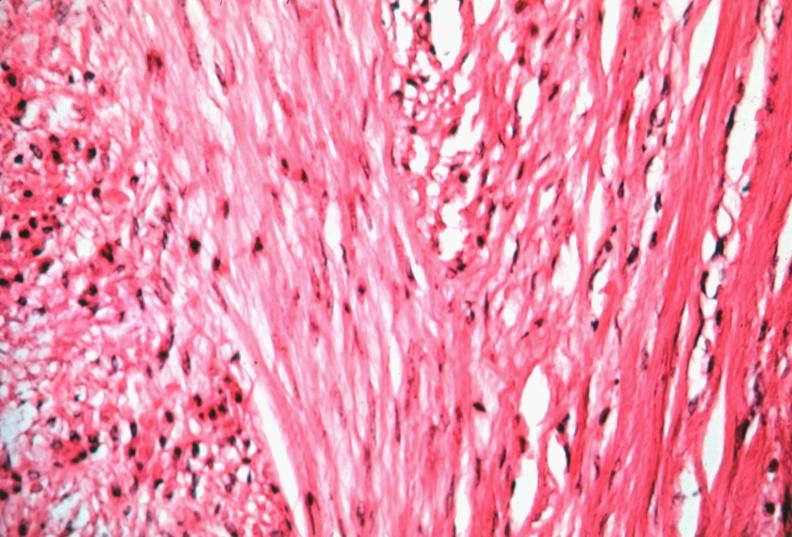s chromophobe adenoma present?
Answer the question using a single word or phrase. No 